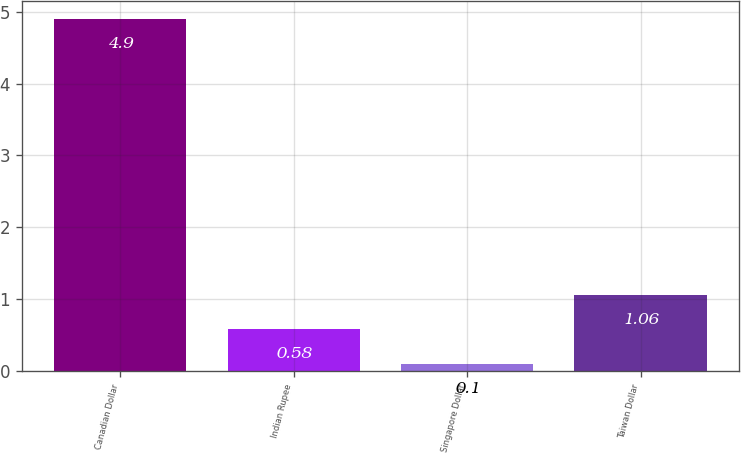Convert chart. <chart><loc_0><loc_0><loc_500><loc_500><bar_chart><fcel>Canadian Dollar<fcel>Indian Rupee<fcel>Singapore Dollar<fcel>Taiwan Dollar<nl><fcel>4.9<fcel>0.58<fcel>0.1<fcel>1.06<nl></chart> 